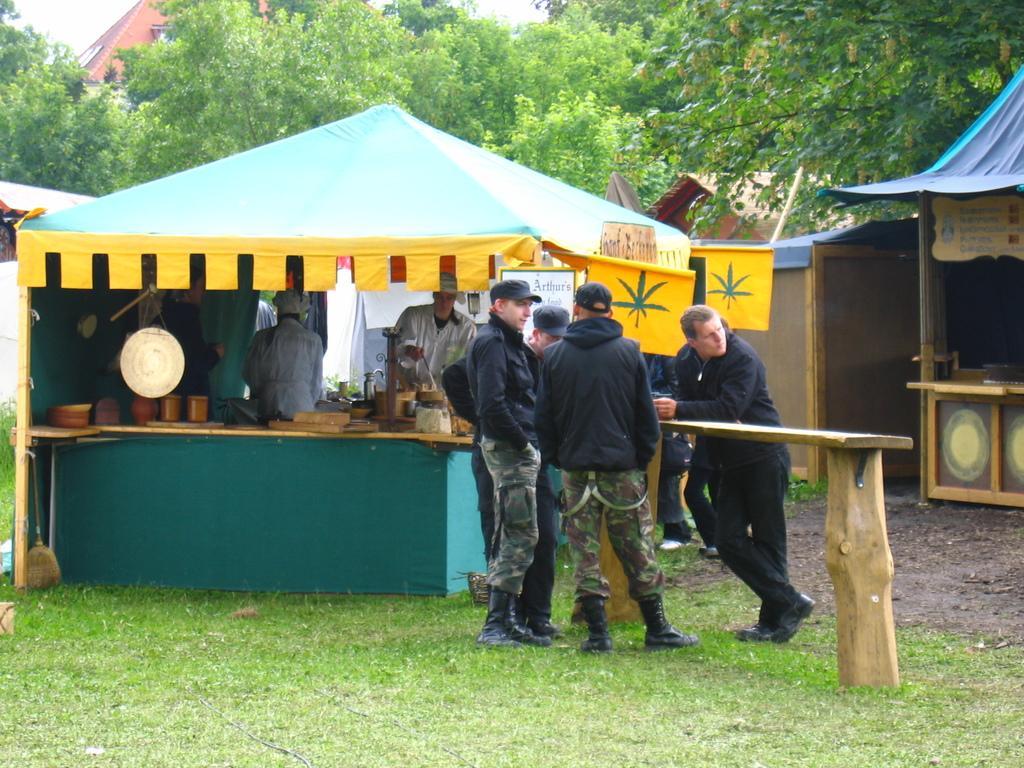Describe this image in one or two sentences. In this image we can see persons at the wooden bench. At the bottom of the image there is a grass. In the background there is a tent, persons, huts, trees, buildings and sky. 